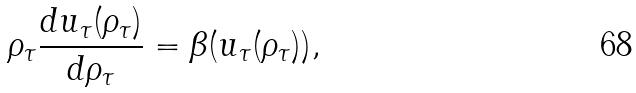Convert formula to latex. <formula><loc_0><loc_0><loc_500><loc_500>\rho _ { \tau } \frac { d u _ { \tau } ( \rho _ { \tau } ) } { d \rho _ { \tau } } = \beta ( u _ { \tau } ( \rho _ { \tau } ) ) ,</formula> 